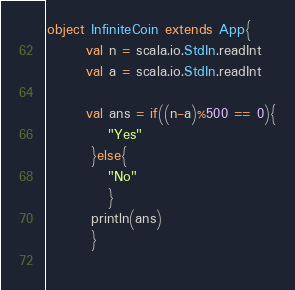<code> <loc_0><loc_0><loc_500><loc_500><_Scala_>object InfiniteCoin extends App{
       val n = scala.io.StdIn.readInt
       val a = scala.io.StdIn.readInt

       val ans = if((n-a)%500 == 0){
           "Yes"
        }else{
           "No"
           }
        println(ans)
        }
        
</code> 